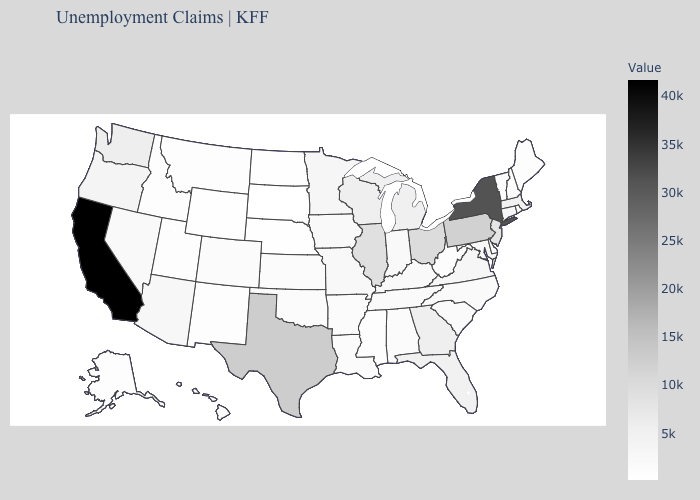Among the states that border Arizona , which have the lowest value?
Answer briefly. New Mexico. Which states have the highest value in the USA?
Answer briefly. California. Among the states that border Oklahoma , does Kansas have the highest value?
Quick response, please. No. Is the legend a continuous bar?
Be succinct. Yes. Does the map have missing data?
Answer briefly. No. Does California have the highest value in the West?
Answer briefly. Yes. Among the states that border Texas , does New Mexico have the highest value?
Short answer required. No. 